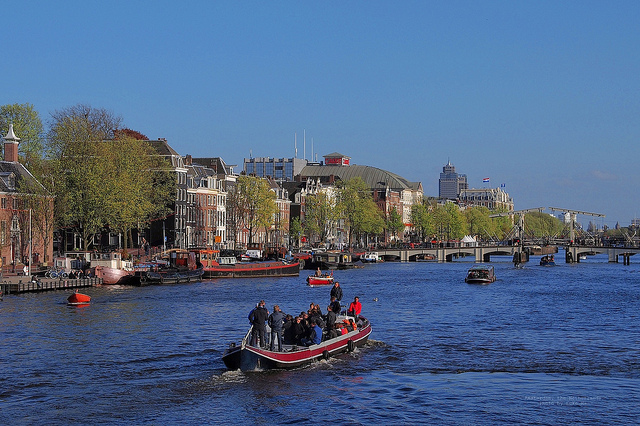<image>Are there any birds? There are no birds in the image. Are there any birds? There are no birds in the image. 